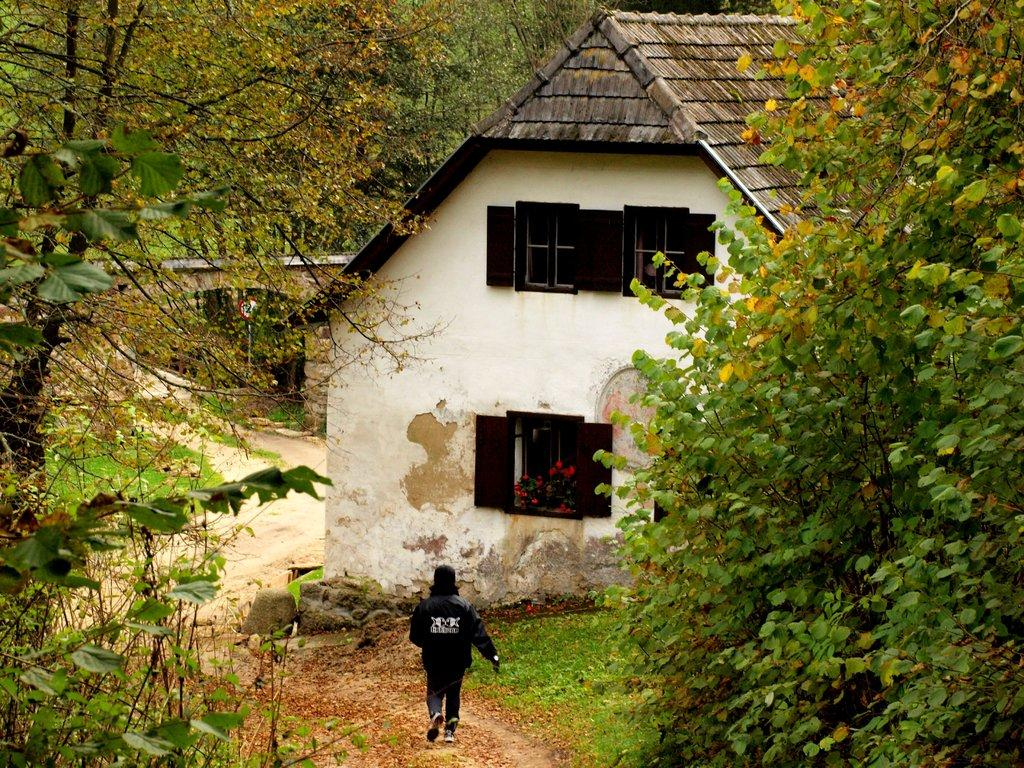Who or what is present in the image? There is a person in the image. What type of natural environment can be seen in the image? There is grass, plants with flowers, and trees in the image. What type of structure is visible in the image? There is a house in the image. What architectural feature can be seen on the house? There are windows in the image. What additional object can be seen in the image? There is a board attached to a pole in the image. What type of noise is being made by the caption in the image? There is no caption present in the image, and therefore no noise can be attributed to it. 